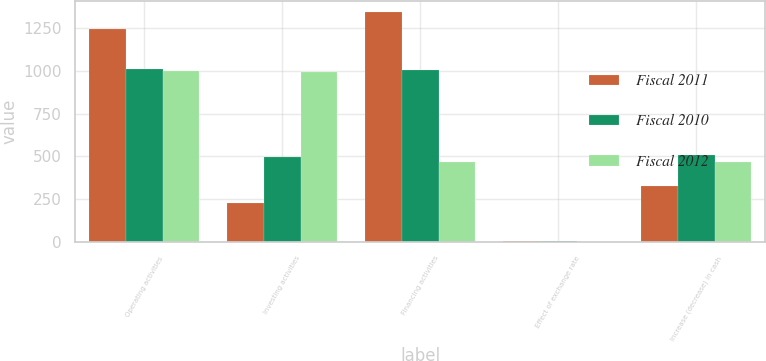<chart> <loc_0><loc_0><loc_500><loc_500><stacked_bar_chart><ecel><fcel>Operating activities<fcel>Investing activities<fcel>Financing activities<fcel>Effect of exchange rate<fcel>Increase (decrease) in cash<nl><fcel>Fiscal 2011<fcel>1246<fcel>225<fcel>1344<fcel>6<fcel>329<nl><fcel>Fiscal 2010<fcel>1013<fcel>497<fcel>1006<fcel>4<fcel>508<nl><fcel>Fiscal 2012<fcel>998<fcel>997<fcel>467<fcel>1<fcel>465<nl></chart> 